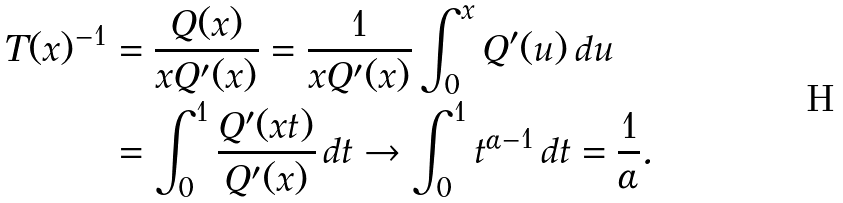Convert formula to latex. <formula><loc_0><loc_0><loc_500><loc_500>T ( x ) ^ { - 1 } & = \frac { Q ( x ) } { x Q ^ { \prime } ( x ) } = \frac { 1 } { x Q ^ { \prime } ( x ) } \int _ { 0 } ^ { x } Q ^ { \prime } ( u ) \, d u \\ & = \int _ { 0 } ^ { 1 } \frac { Q ^ { \prime } ( x t ) } { Q ^ { \prime } ( x ) } \, d t \rightarrow \int _ { 0 } ^ { 1 } t ^ { \alpha - 1 } \, d t = \frac { 1 } { \alpha } .</formula> 